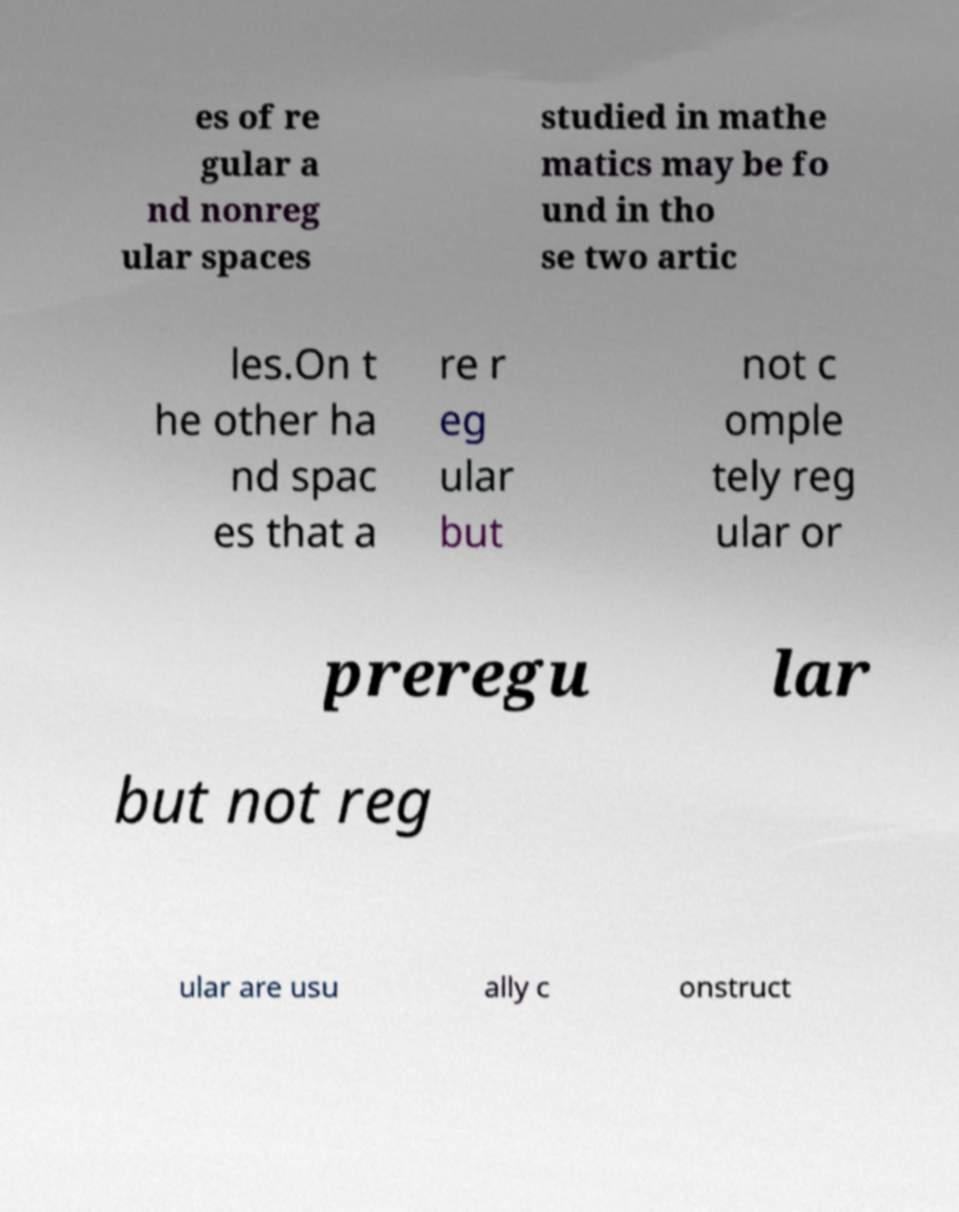Can you read and provide the text displayed in the image?This photo seems to have some interesting text. Can you extract and type it out for me? es of re gular a nd nonreg ular spaces studied in mathe matics may be fo und in tho se two artic les.On t he other ha nd spac es that a re r eg ular but not c omple tely reg ular or preregu lar but not reg ular are usu ally c onstruct 